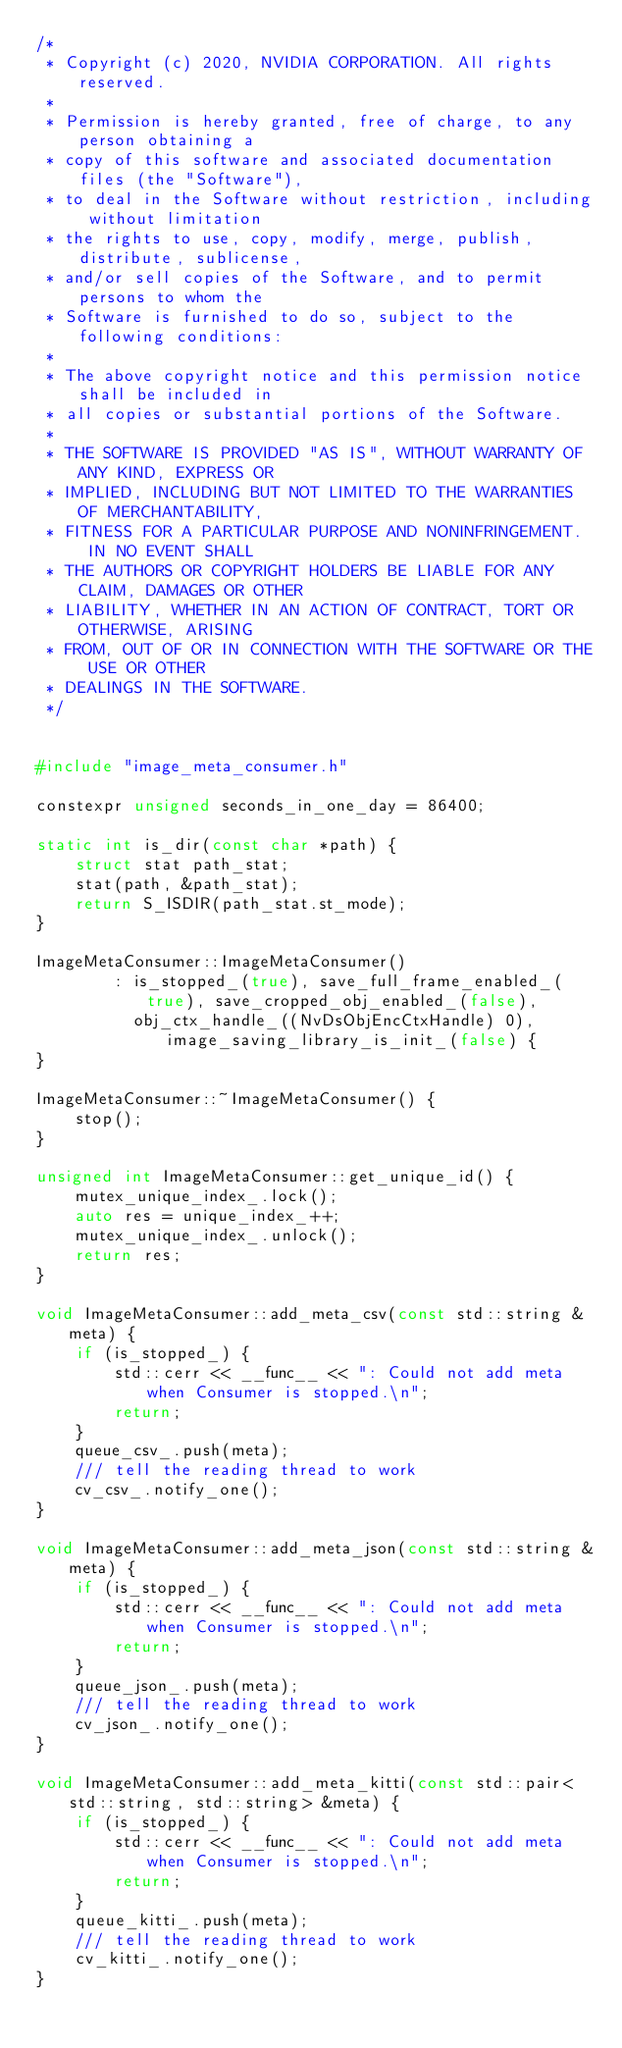<code> <loc_0><loc_0><loc_500><loc_500><_C++_>/*
 * Copyright (c) 2020, NVIDIA CORPORATION. All rights reserved.
 *
 * Permission is hereby granted, free of charge, to any person obtaining a
 * copy of this software and associated documentation files (the "Software"),
 * to deal in the Software without restriction, including without limitation
 * the rights to use, copy, modify, merge, publish, distribute, sublicense,
 * and/or sell copies of the Software, and to permit persons to whom the
 * Software is furnished to do so, subject to the following conditions:
 *
 * The above copyright notice and this permission notice shall be included in
 * all copies or substantial portions of the Software.
 *
 * THE SOFTWARE IS PROVIDED "AS IS", WITHOUT WARRANTY OF ANY KIND, EXPRESS OR
 * IMPLIED, INCLUDING BUT NOT LIMITED TO THE WARRANTIES OF MERCHANTABILITY,
 * FITNESS FOR A PARTICULAR PURPOSE AND NONINFRINGEMENT.  IN NO EVENT SHALL
 * THE AUTHORS OR COPYRIGHT HOLDERS BE LIABLE FOR ANY CLAIM, DAMAGES OR OTHER
 * LIABILITY, WHETHER IN AN ACTION OF CONTRACT, TORT OR OTHERWISE, ARISING
 * FROM, OUT OF OR IN CONNECTION WITH THE SOFTWARE OR THE USE OR OTHER
 * DEALINGS IN THE SOFTWARE.
 */


#include "image_meta_consumer.h"

constexpr unsigned seconds_in_one_day = 86400;

static int is_dir(const char *path) {
    struct stat path_stat;
    stat(path, &path_stat);
    return S_ISDIR(path_stat.st_mode);
}

ImageMetaConsumer::ImageMetaConsumer()
        : is_stopped_(true), save_full_frame_enabled_(true), save_cropped_obj_enabled_(false),
          obj_ctx_handle_((NvDsObjEncCtxHandle) 0), image_saving_library_is_init_(false) {
}

ImageMetaConsumer::~ImageMetaConsumer() {
    stop();
}

unsigned int ImageMetaConsumer::get_unique_id() {
    mutex_unique_index_.lock();
    auto res = unique_index_++;
    mutex_unique_index_.unlock();
    return res;
}

void ImageMetaConsumer::add_meta_csv(const std::string &meta) {
    if (is_stopped_) {
        std::cerr << __func__ << ": Could not add meta when Consumer is stopped.\n";
        return;
    }
    queue_csv_.push(meta);
    /// tell the reading thread to work
    cv_csv_.notify_one();
}

void ImageMetaConsumer::add_meta_json(const std::string &meta) {
    if (is_stopped_) {
        std::cerr << __func__ << ": Could not add meta when Consumer is stopped.\n";
        return;
    }
    queue_json_.push(meta);
    /// tell the reading thread to work
    cv_json_.notify_one();
}

void ImageMetaConsumer::add_meta_kitti(const std::pair<std::string, std::string> &meta) {
    if (is_stopped_) {
        std::cerr << __func__ << ": Could not add meta when Consumer is stopped.\n";
        return;
    }
    queue_kitti_.push(meta);
    /// tell the reading thread to work
    cv_kitti_.notify_one();
}
</code> 